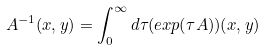Convert formula to latex. <formula><loc_0><loc_0><loc_500><loc_500>A ^ { - 1 } ( x , y ) = \int _ { 0 } ^ { \infty } d \tau ( e x p ( \tau A ) ) ( x , y )</formula> 